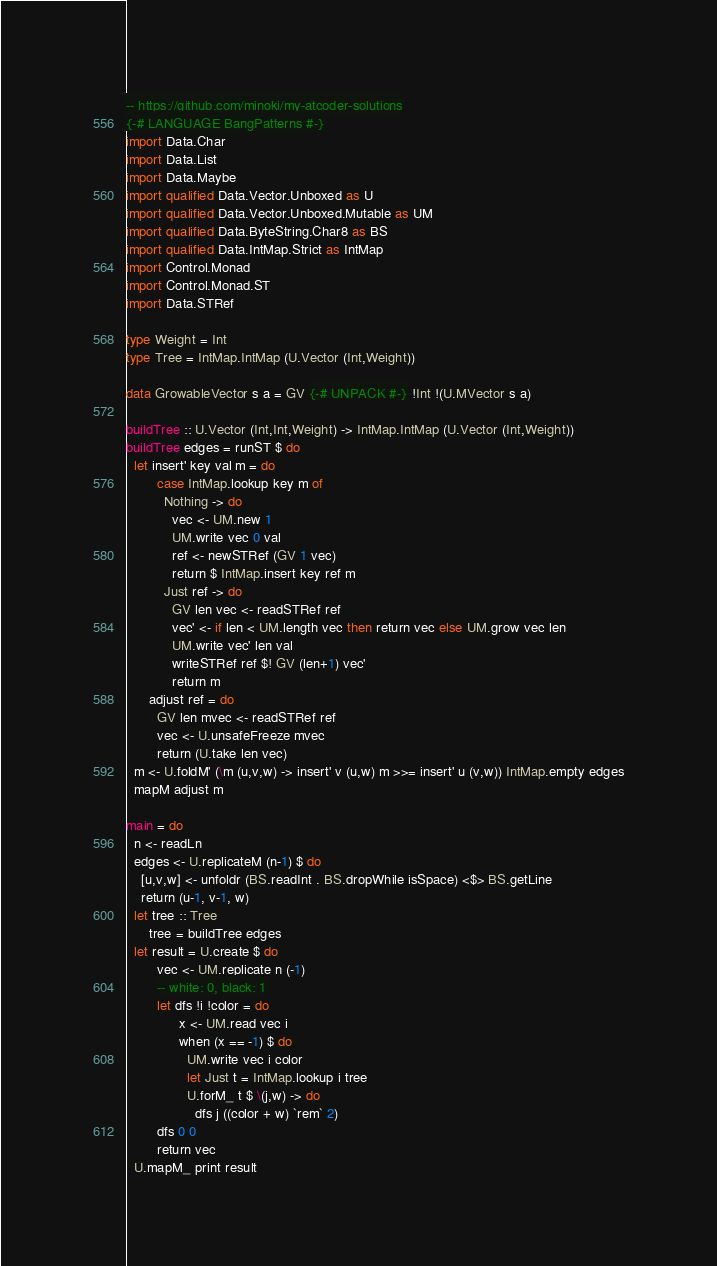Convert code to text. <code><loc_0><loc_0><loc_500><loc_500><_Haskell_>-- https://github.com/minoki/my-atcoder-solutions
{-# LANGUAGE BangPatterns #-}
import Data.Char
import Data.List
import Data.Maybe
import qualified Data.Vector.Unboxed as U
import qualified Data.Vector.Unboxed.Mutable as UM
import qualified Data.ByteString.Char8 as BS
import qualified Data.IntMap.Strict as IntMap
import Control.Monad
import Control.Monad.ST
import Data.STRef

type Weight = Int
type Tree = IntMap.IntMap (U.Vector (Int,Weight))

data GrowableVector s a = GV {-# UNPACK #-} !Int !(U.MVector s a)

buildTree :: U.Vector (Int,Int,Weight) -> IntMap.IntMap (U.Vector (Int,Weight))
buildTree edges = runST $ do
  let insert' key val m = do
        case IntMap.lookup key m of
          Nothing -> do
            vec <- UM.new 1
            UM.write vec 0 val
            ref <- newSTRef (GV 1 vec)
            return $ IntMap.insert key ref m
          Just ref -> do
            GV len vec <- readSTRef ref
            vec' <- if len < UM.length vec then return vec else UM.grow vec len
            UM.write vec' len val
            writeSTRef ref $! GV (len+1) vec'
            return m
      adjust ref = do
        GV len mvec <- readSTRef ref
        vec <- U.unsafeFreeze mvec
        return (U.take len vec)
  m <- U.foldM' (\m (u,v,w) -> insert' v (u,w) m >>= insert' u (v,w)) IntMap.empty edges
  mapM adjust m

main = do
  n <- readLn
  edges <- U.replicateM (n-1) $ do
    [u,v,w] <- unfoldr (BS.readInt . BS.dropWhile isSpace) <$> BS.getLine
    return (u-1, v-1, w)
  let tree :: Tree
      tree = buildTree edges
  let result = U.create $ do
        vec <- UM.replicate n (-1)
        -- white: 0, black: 1
        let dfs !i !color = do
              x <- UM.read vec i
              when (x == -1) $ do
                UM.write vec i color
                let Just t = IntMap.lookup i tree
                U.forM_ t $ \(j,w) -> do
                  dfs j ((color + w) `rem` 2)
        dfs 0 0
        return vec
  U.mapM_ print result
</code> 